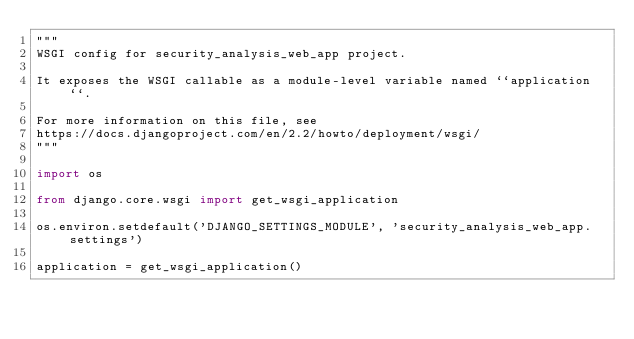<code> <loc_0><loc_0><loc_500><loc_500><_Python_>"""
WSGI config for security_analysis_web_app project.

It exposes the WSGI callable as a module-level variable named ``application``.

For more information on this file, see
https://docs.djangoproject.com/en/2.2/howto/deployment/wsgi/
"""

import os

from django.core.wsgi import get_wsgi_application

os.environ.setdefault('DJANGO_SETTINGS_MODULE', 'security_analysis_web_app.settings')

application = get_wsgi_application()
</code> 